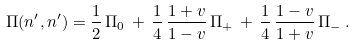Convert formula to latex. <formula><loc_0><loc_0><loc_500><loc_500>\Pi ( n ^ { \prime } , n ^ { \prime } ) = \frac { 1 } { 2 } \, \Pi _ { 0 } \, + \, \frac { 1 } { 4 } \, \frac { 1 + v } { 1 - v } \, \Pi _ { + } \, + \, \frac { 1 } { 4 } \, \frac { 1 - v } { 1 + v } \, \Pi _ { - } \, .</formula> 